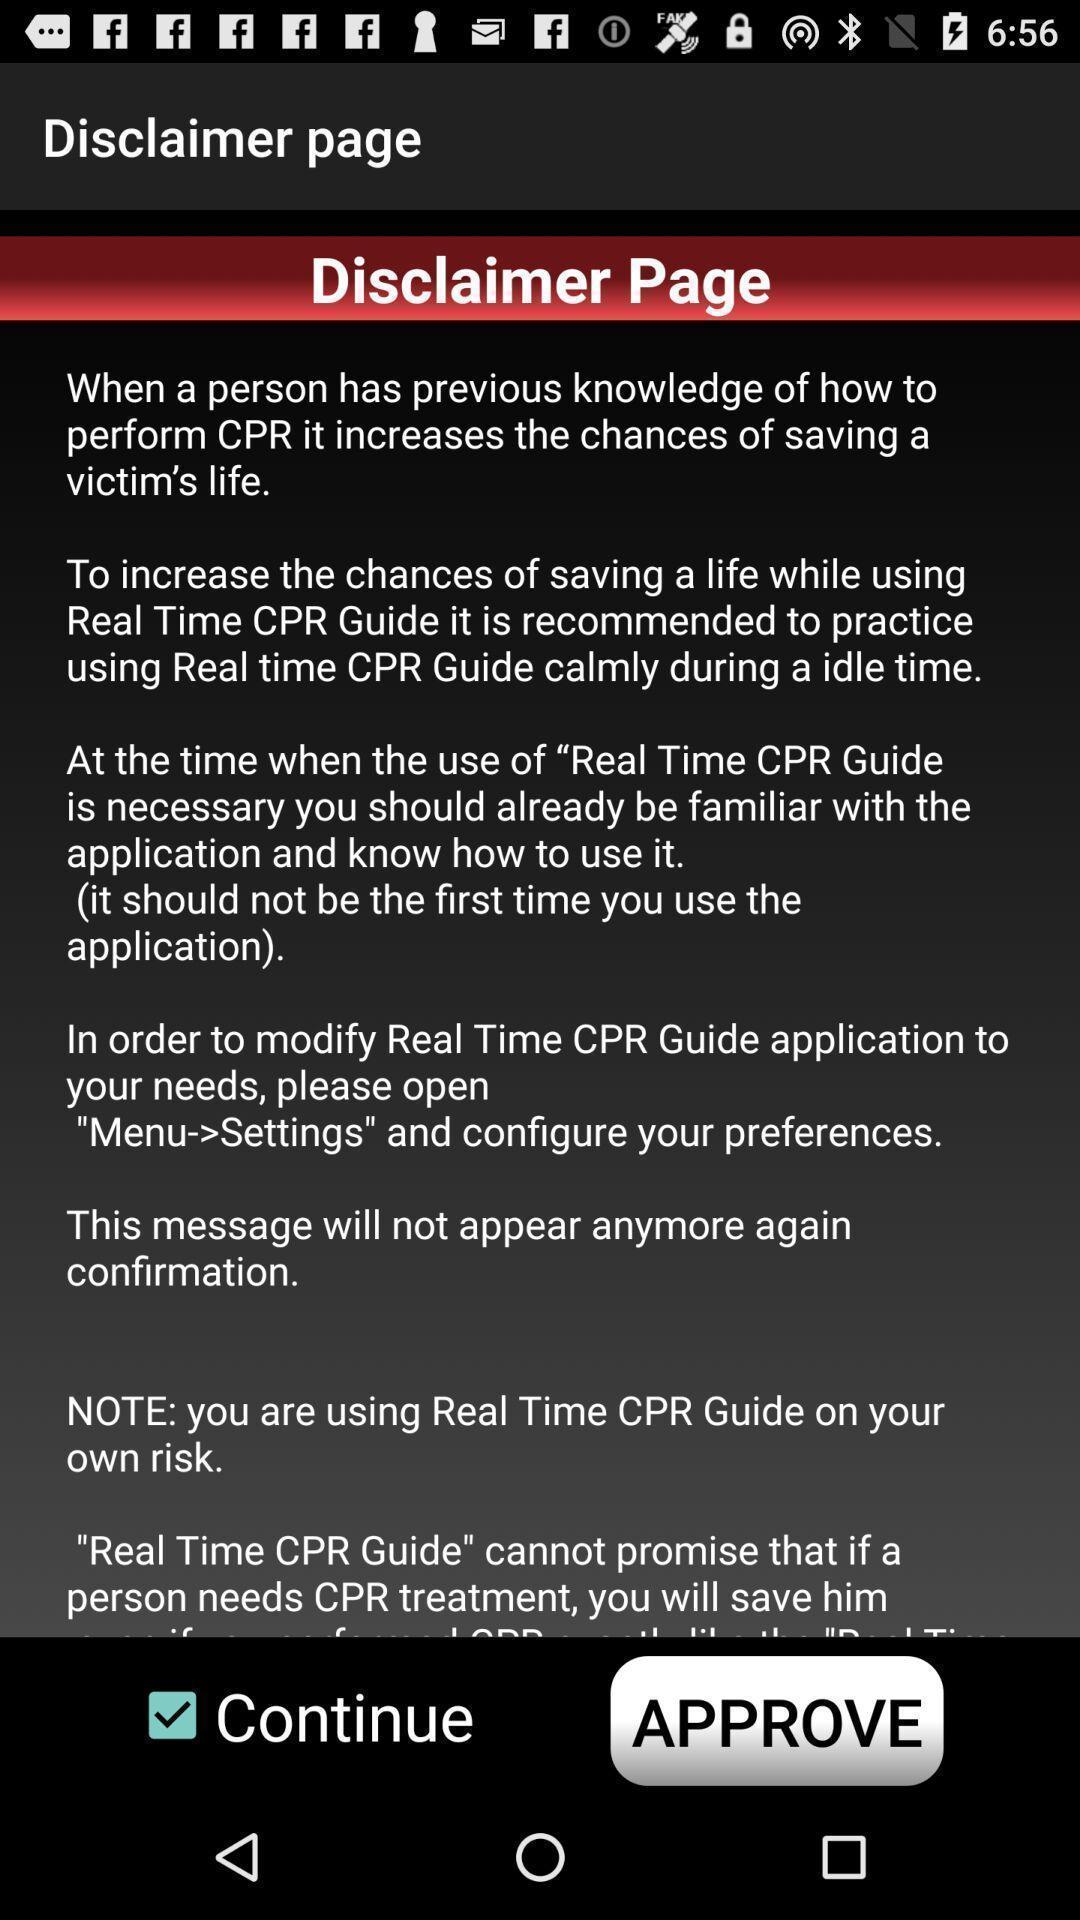Describe the content in this image. Page showing option like continue. 